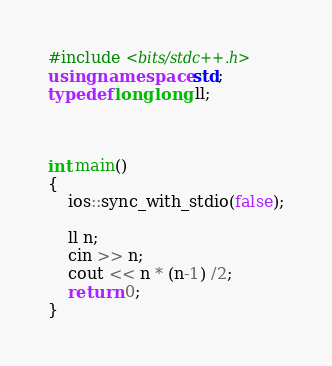Convert code to text. <code><loc_0><loc_0><loc_500><loc_500><_C++_>#include <bits/stdc++.h>
using namespace std;
typedef long long ll;



int main()
{
    ios::sync_with_stdio(false);

    ll n;
    cin >> n;
    cout << n * (n-1) /2;
    return 0;
}
</code> 